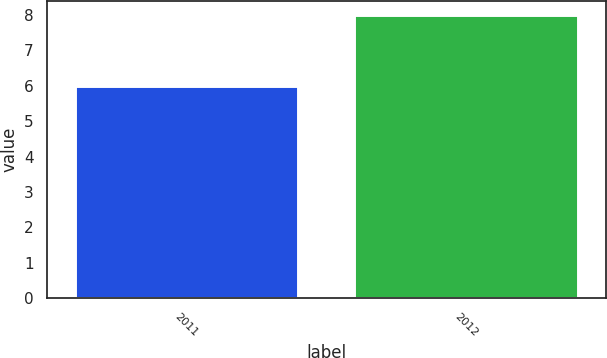Convert chart to OTSL. <chart><loc_0><loc_0><loc_500><loc_500><bar_chart><fcel>2011<fcel>2012<nl><fcel>6<fcel>8<nl></chart> 